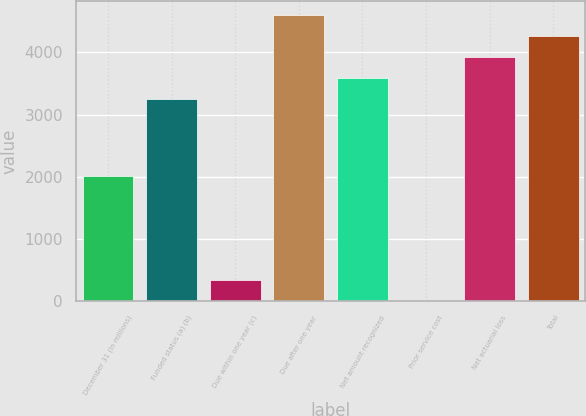<chart> <loc_0><loc_0><loc_500><loc_500><bar_chart><fcel>December 31 (In millions)<fcel>Funded status (a) (b)<fcel>Due within one year (c)<fcel>Due after one year<fcel>Net amount recognized<fcel>Prior service cost<fcel>Net actuarial loss<fcel>Total<nl><fcel>2011<fcel>3256<fcel>339.8<fcel>4599.2<fcel>3591.8<fcel>4<fcel>3927.6<fcel>4263.4<nl></chart> 